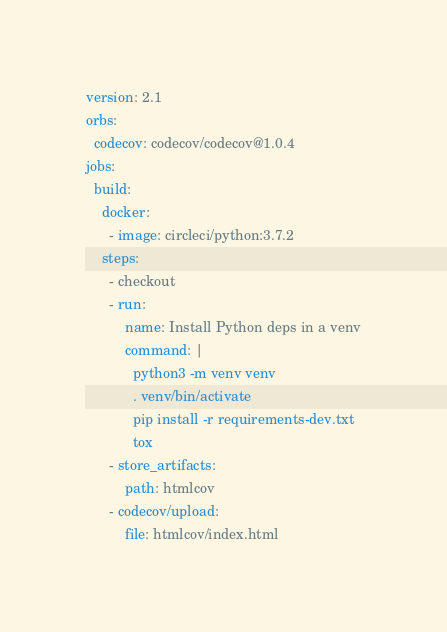Convert code to text. <code><loc_0><loc_0><loc_500><loc_500><_YAML_>version: 2.1
orbs:
  codecov: codecov/codecov@1.0.4
jobs:
  build:
    docker:
      - image: circleci/python:3.7.2
    steps:
      - checkout
      - run:
          name: Install Python deps in a venv
          command: |
            python3 -m venv venv
            . venv/bin/activate
            pip install -r requirements-dev.txt
            tox
      - store_artifacts:
          path: htmlcov
      - codecov/upload:
          file: htmlcov/index.html
</code> 